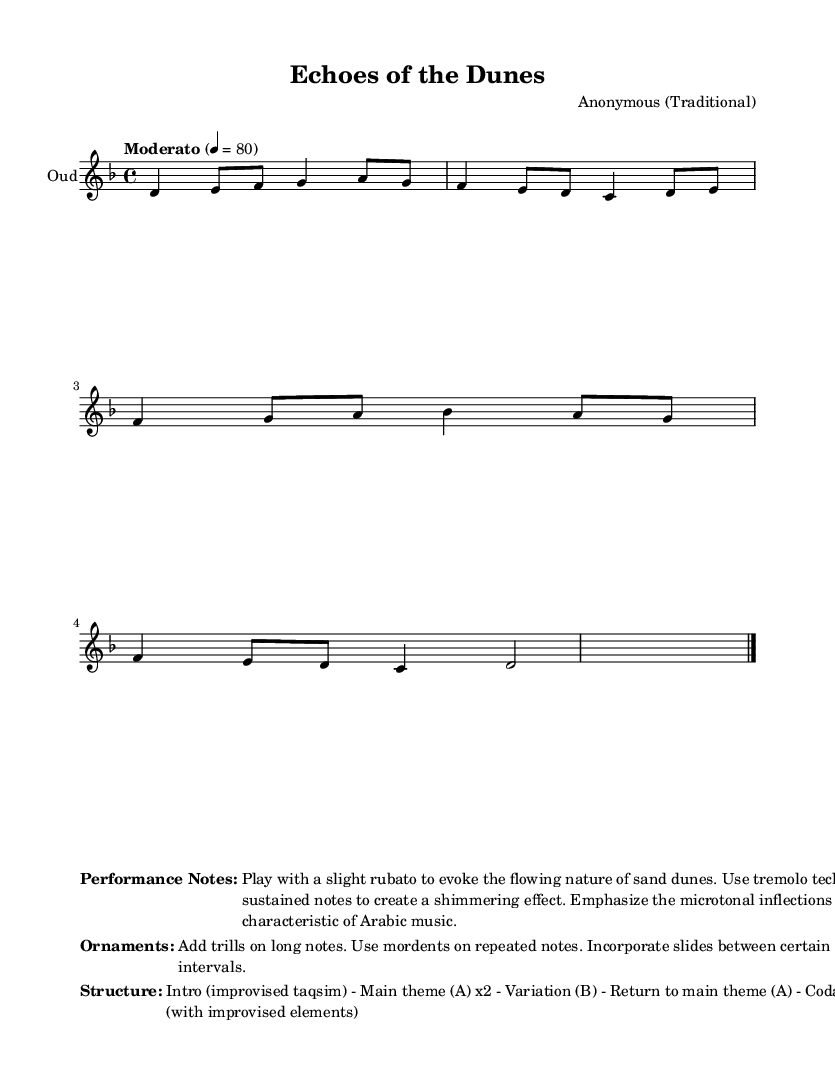What is the key signature of this music? The key signature indicated in the music is D minor, which contains one flat (B flat).
Answer: D minor What is the time signature of this piece? The time signature shown at the beginning is 4/4, indicating four beats per measure.
Answer: 4/4 What is the tempo marking of the piece? The tempo marking states "Moderato" with a metronome marking of 80 beats per minute.
Answer: Moderato, 80 How many times is the main theme (A) played? The main theme (A) is noted to be played twice in the structure section of the music.
Answer: 2 What technique should be used on sustained notes? The performance notes indicate to use tremolo technique on sustained notes to create a shimmering effect.
Answer: Tremolo What ornament is suggested for long notes? The performance notes specify adding trills on long notes as a decorative technique.
Answer: Trills What is the structure of the music? The structure of the music consists of an intro, main theme (A) repeated, a variation (B), return to main theme (A), and a coda.
Answer: Intro, A x2, B, A, Coda 